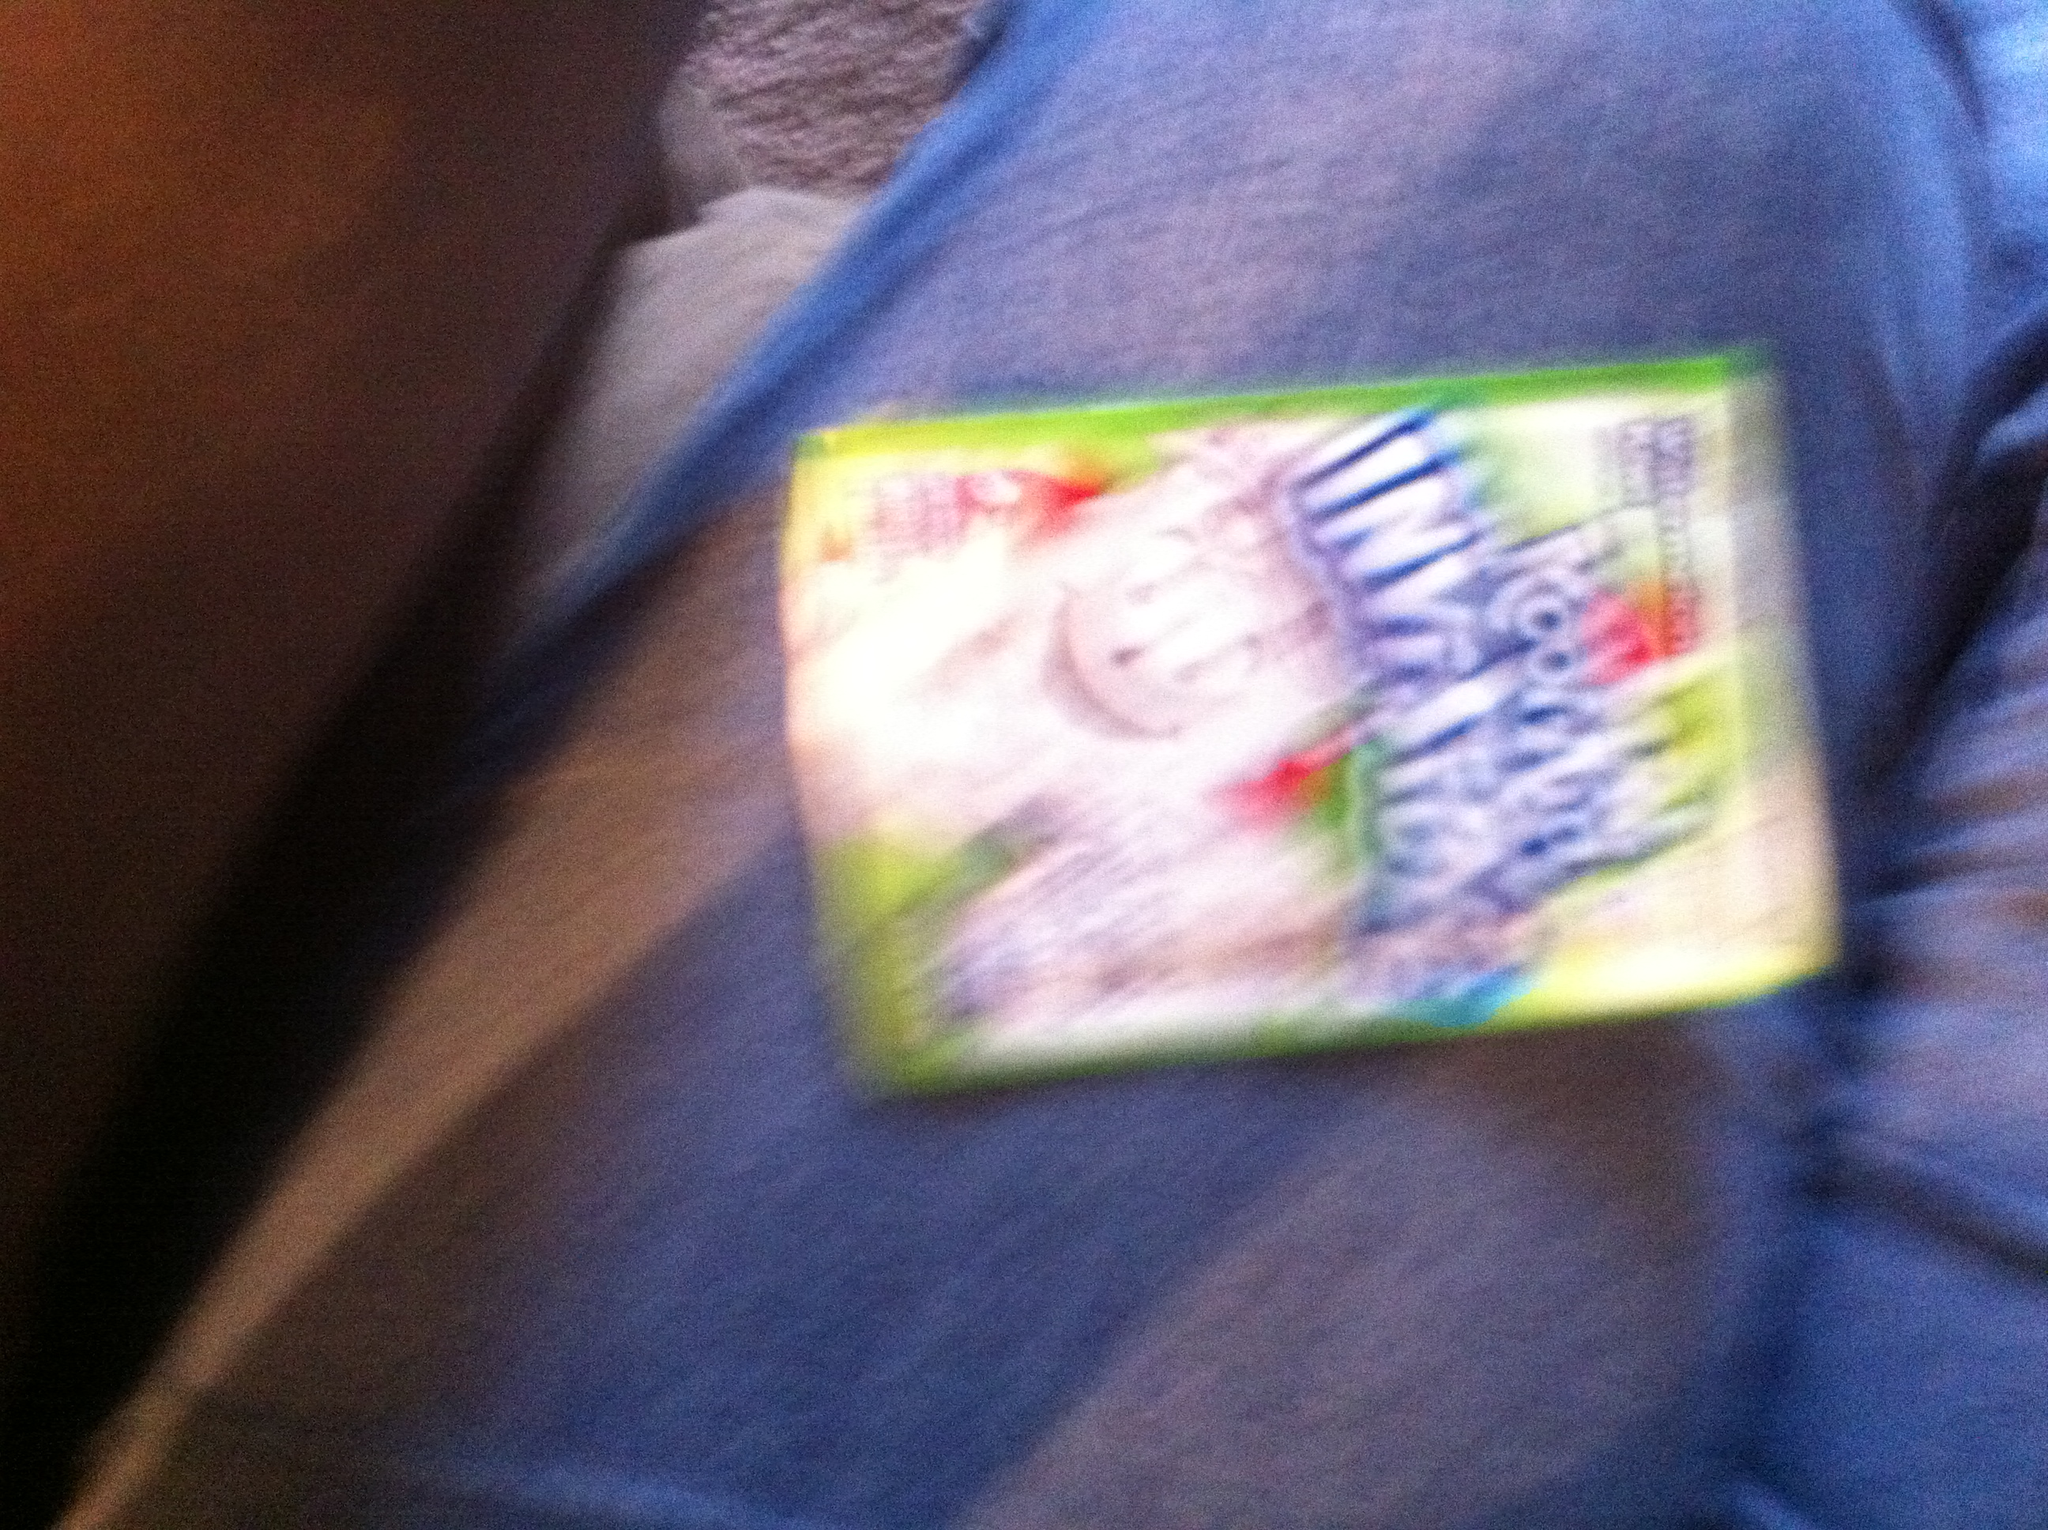Can you tell me more about this product and its marketing appeal? Certainly! The product shown is a type of flavored drink mix that's marketed as 'invisible,' which typically means that it is clear or colorless. This can be appealing to consumers who are looking for a fun and novel experience. Drinking a flavorful beverage that lacks color can be unexpected and interesting. The novelty factor also plays a role in encouraging purchases, as customers might be curious to try something different from the brightly colored drinks that are more common in the market. 